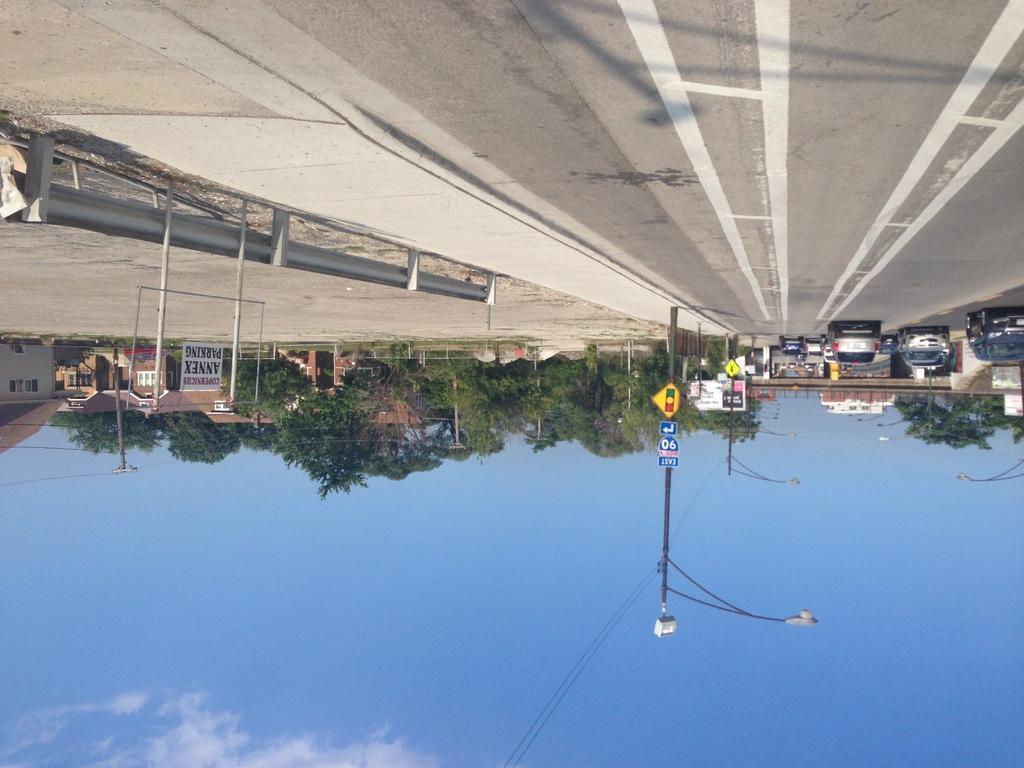In one or two sentences, can you explain what this image depicts? In this picture we can see the buildings, trees, boards, poles, lights, wires, vehicles. At the top of the image we can see the road. On the left side of the image we can see the railing. At the bottom of the image we can see the wires and clouds are present in the sky. 